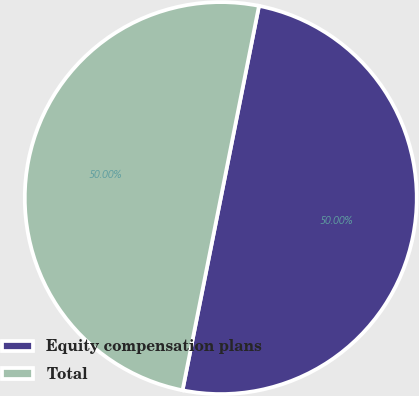<chart> <loc_0><loc_0><loc_500><loc_500><pie_chart><fcel>Equity compensation plans<fcel>Total<nl><fcel>50.0%<fcel>50.0%<nl></chart> 